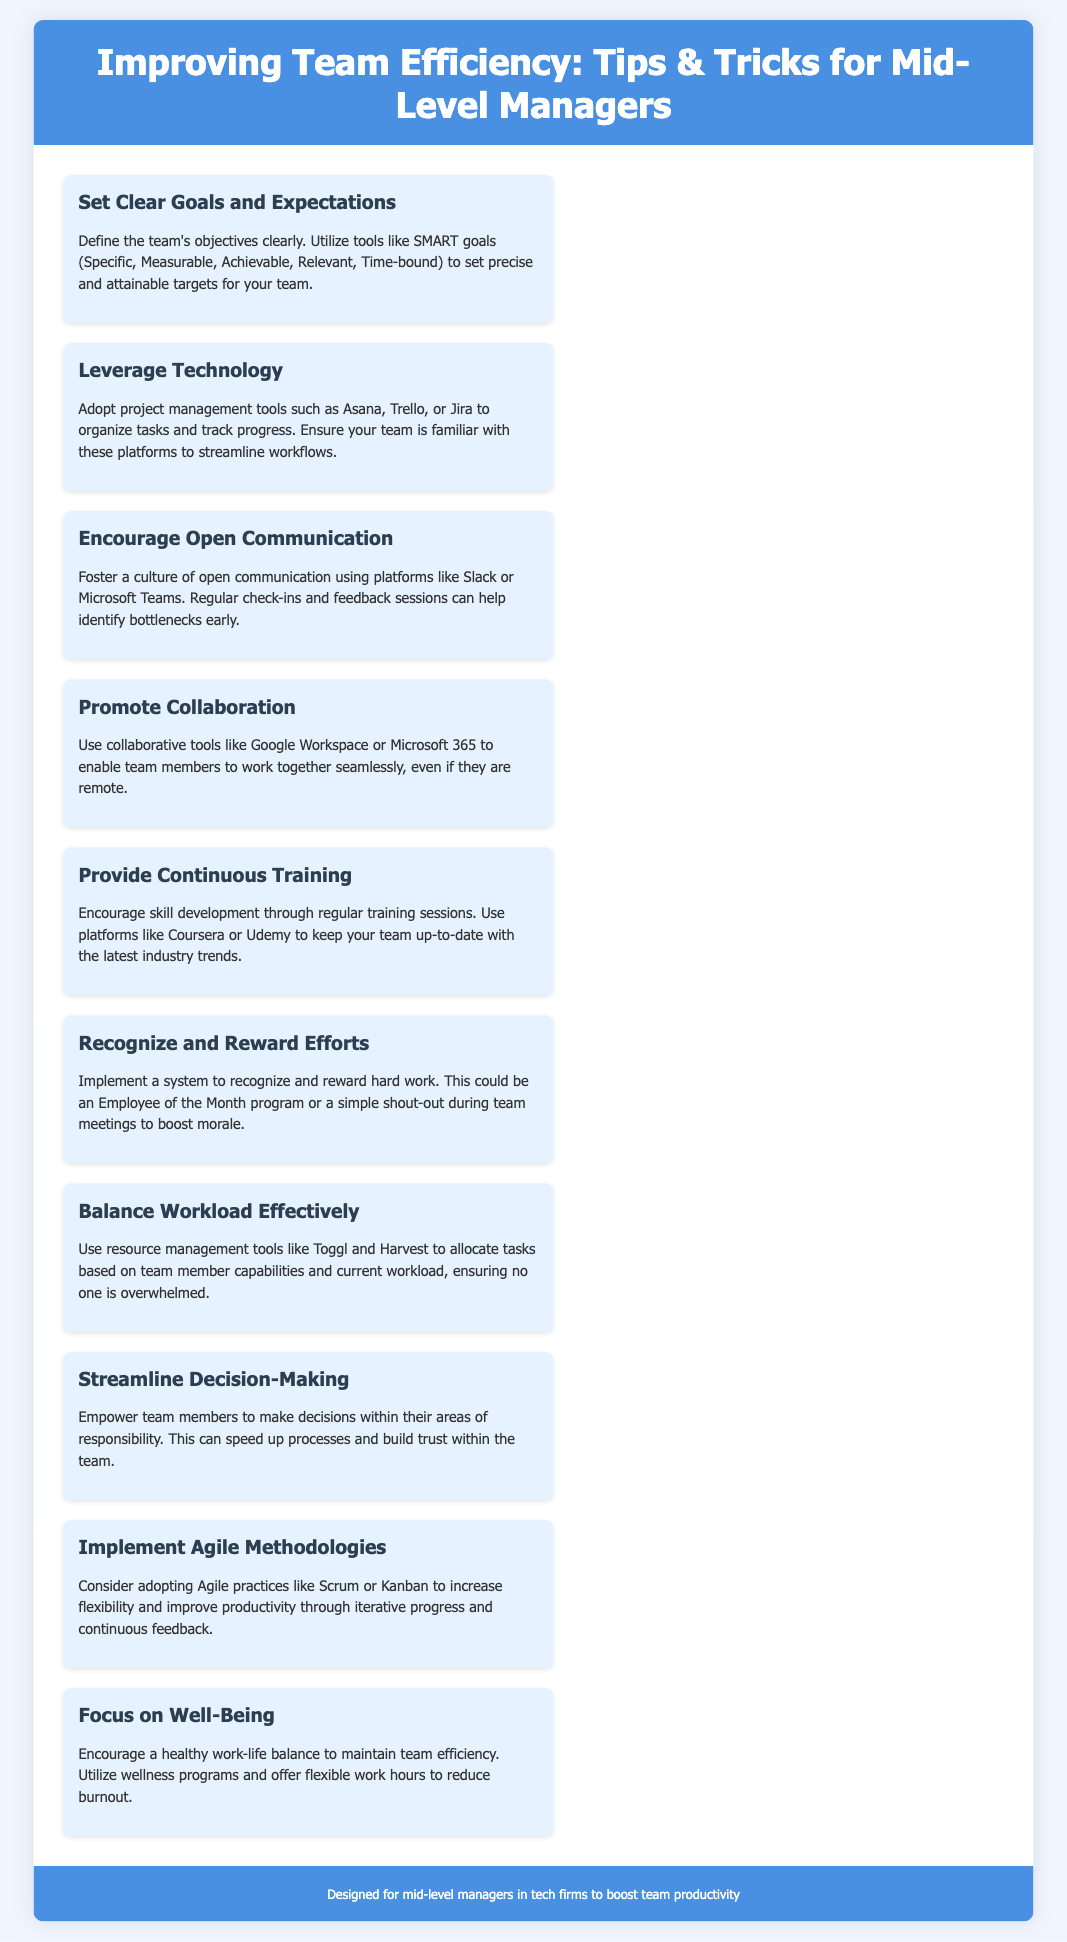What are SMART goals? SMART goals are defined as Specific, Measurable, Achievable, Relevant, Time-bound objectives for teams.
Answer: Specific, Measurable, Achievable, Relevant, Time-bound Which tools are suggested for project management? The document suggests tools like Asana, Trello, or Jira for organizing tasks and tracking progress.
Answer: Asana, Trello, Jira What is the purpose of promoting collaboration? The goal of promoting collaboration is to enable team members to work together seamlessly, even if they are remote.
Answer: Seamlessly work together How can team efforts be recognized? The document states that recognizing efforts could be through an Employee of the Month program or shout-outs in meetings.
Answer: Employee of the Month program or shout-outs What methodologies are recommended to improve productivity? Agile practices like Scrum or Kanban are recommended in the document as ways to improve productivity.
Answer: Scrum or Kanban What should be balanced effectively in a team? The document emphasizes the importance of balancing workload effectively among team members.
Answer: Workload What main benefit does focusing on well-being provide? Focusing on well-being helps maintain team efficiency by reducing burnout.
Answer: Maintain team efficiency How are continuous training sessions beneficial? Continuous training sessions are beneficial for encouraging skill development and keeping the team updated with industry trends.
Answer: Encouraging skill development What is the target audience of the flyer? The flyer is designed specifically for mid-level managers in tech firms.
Answer: Mid-level managers in tech firms 